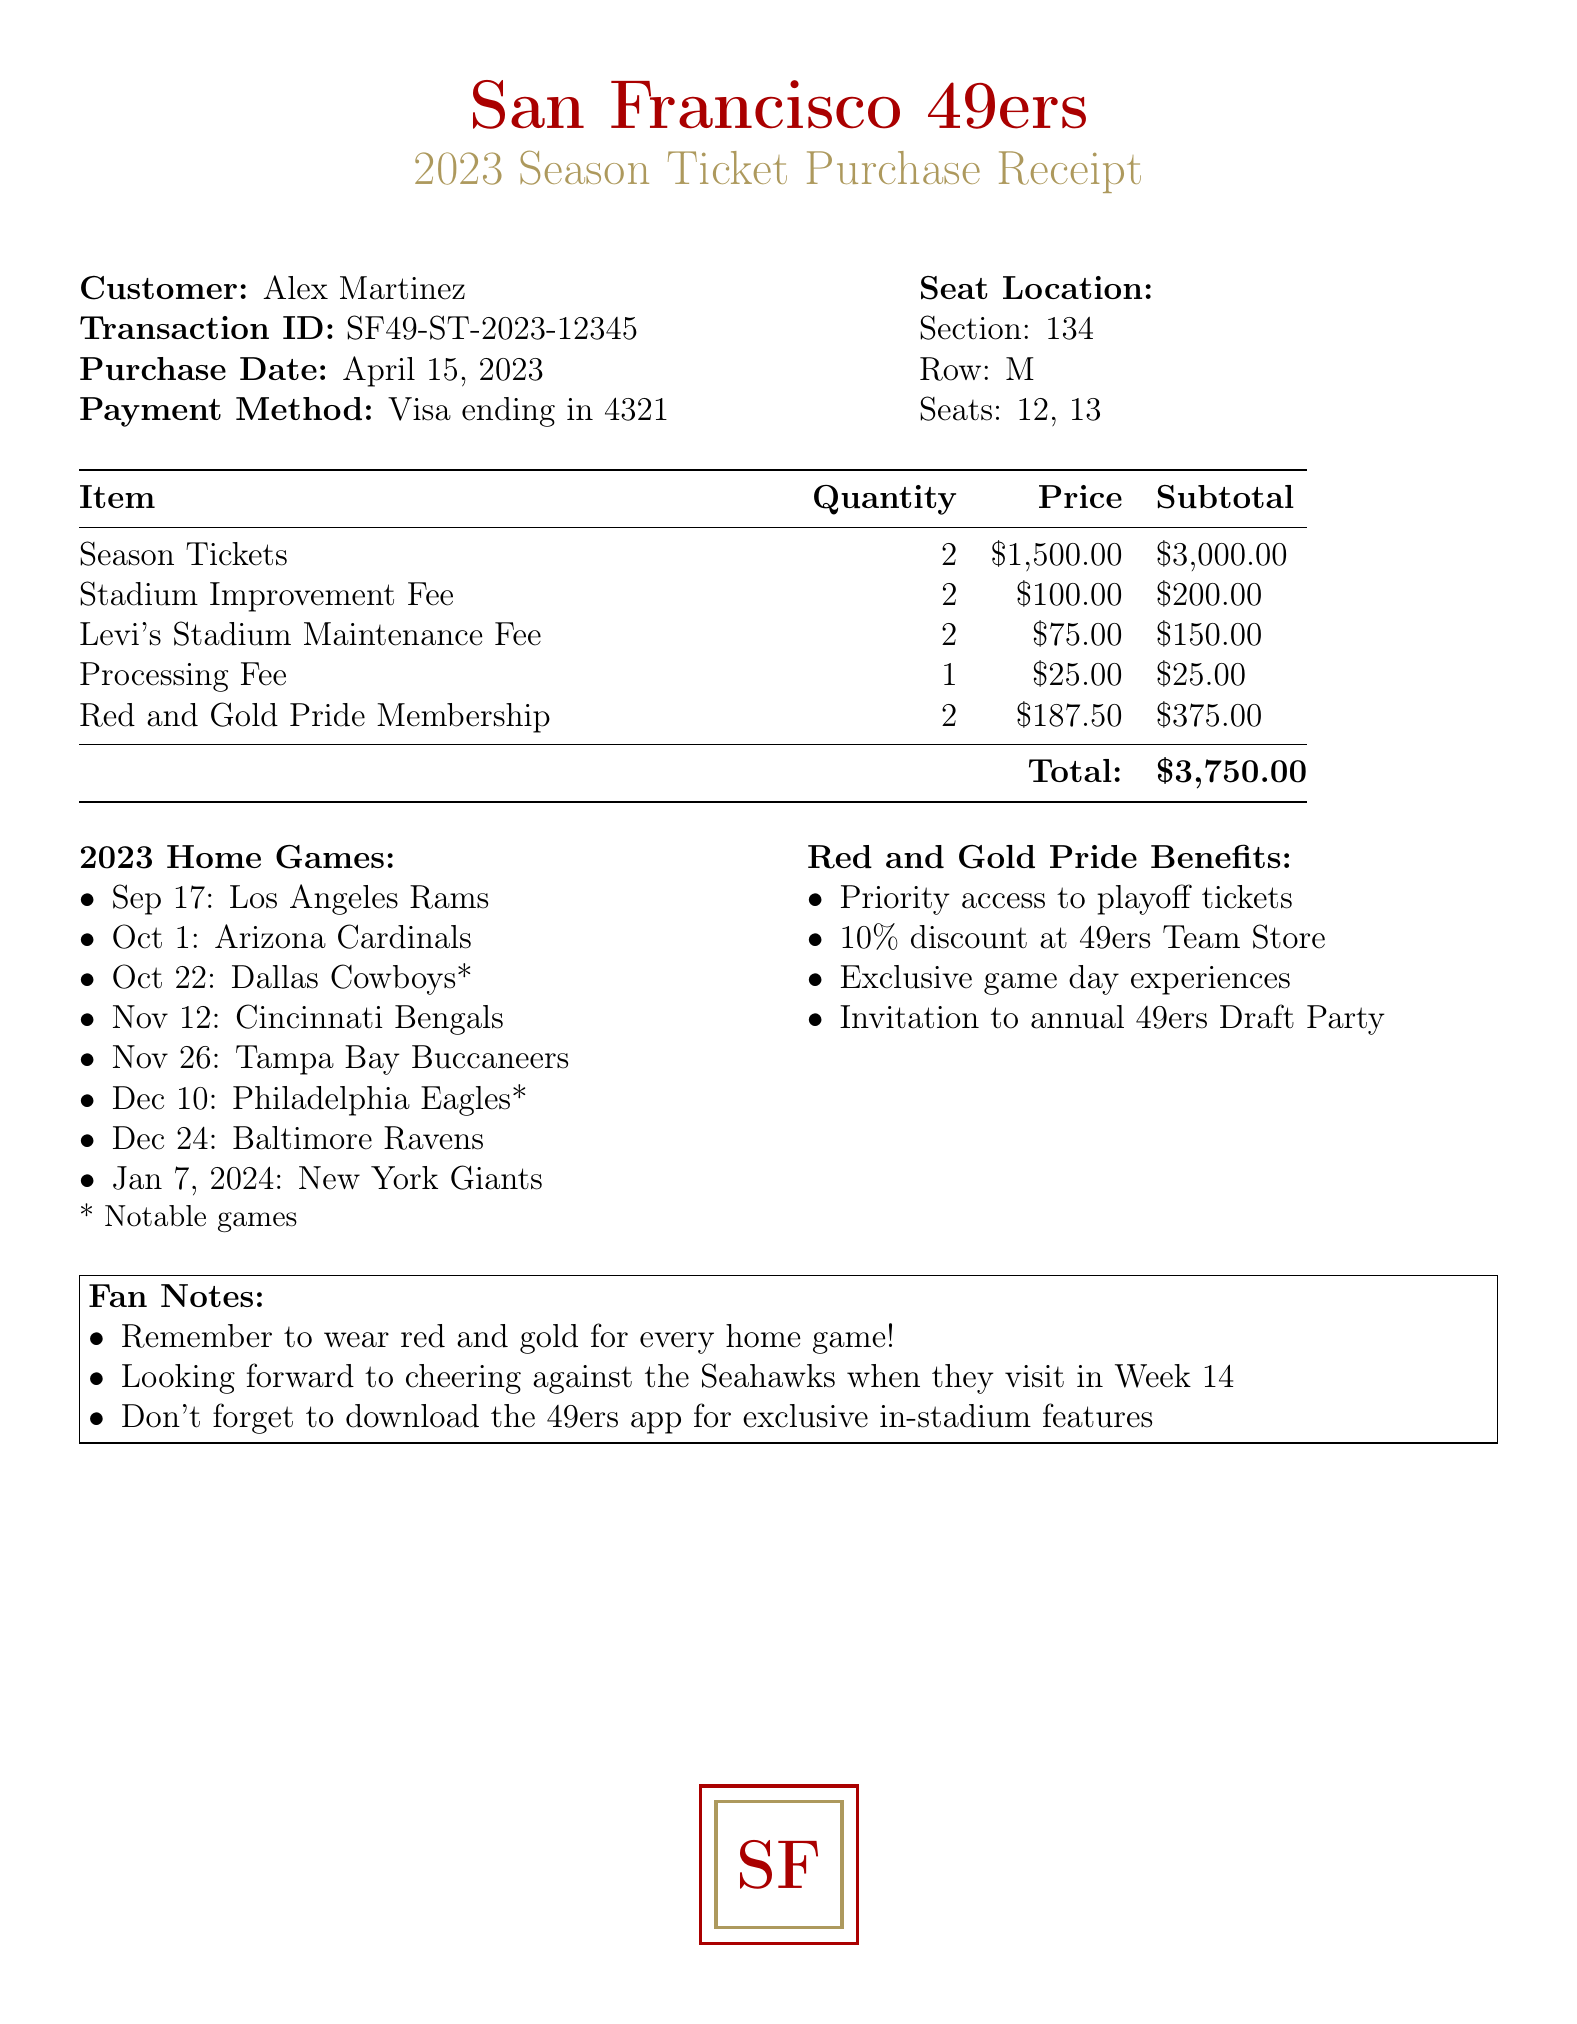What is the transaction ID? The transaction ID is a unique identifier for the purchase.
Answer: SF49-ST-2023-12345 Who is the customer? The customer name is provided in the document.
Answer: Alex Martinez What was the purchase date? The purchase date indicates when the tickets were bought.
Answer: April 15, 2023 How many seats were purchased? The quantity of seats can be summed from the seat locations provided.
Answer: 2 What is the total cost? The total cost is listed at the bottom of the cost breakdown section.
Answer: $3750.00 How much is the stadium improvement fee for one ticket? The price per item for the stadium improvement fee indicates its individual cost.
Answer: $100.00 Which team do the 49ers play on October 22, 2023? The opponent for the game on that date is mentioned in the home games list.
Answer: Dallas Cowboys What is one benefit of the Red and Gold Pride Membership? The document lists benefits that come with the membership.
Answer: Priority access to playoff tickets In which row are the purchased seats located? The row information is specified in the seat locations section.
Answer: M What is the price of the season parking pass? The parking information includes the cost for the parking pass.
Answer: $500.00 